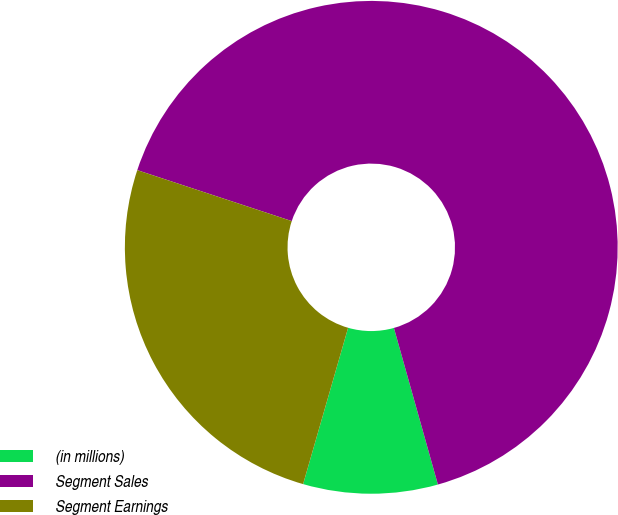Convert chart. <chart><loc_0><loc_0><loc_500><loc_500><pie_chart><fcel>(in millions)<fcel>Segment Sales<fcel>Segment Earnings<nl><fcel>8.82%<fcel>65.57%<fcel>25.61%<nl></chart> 